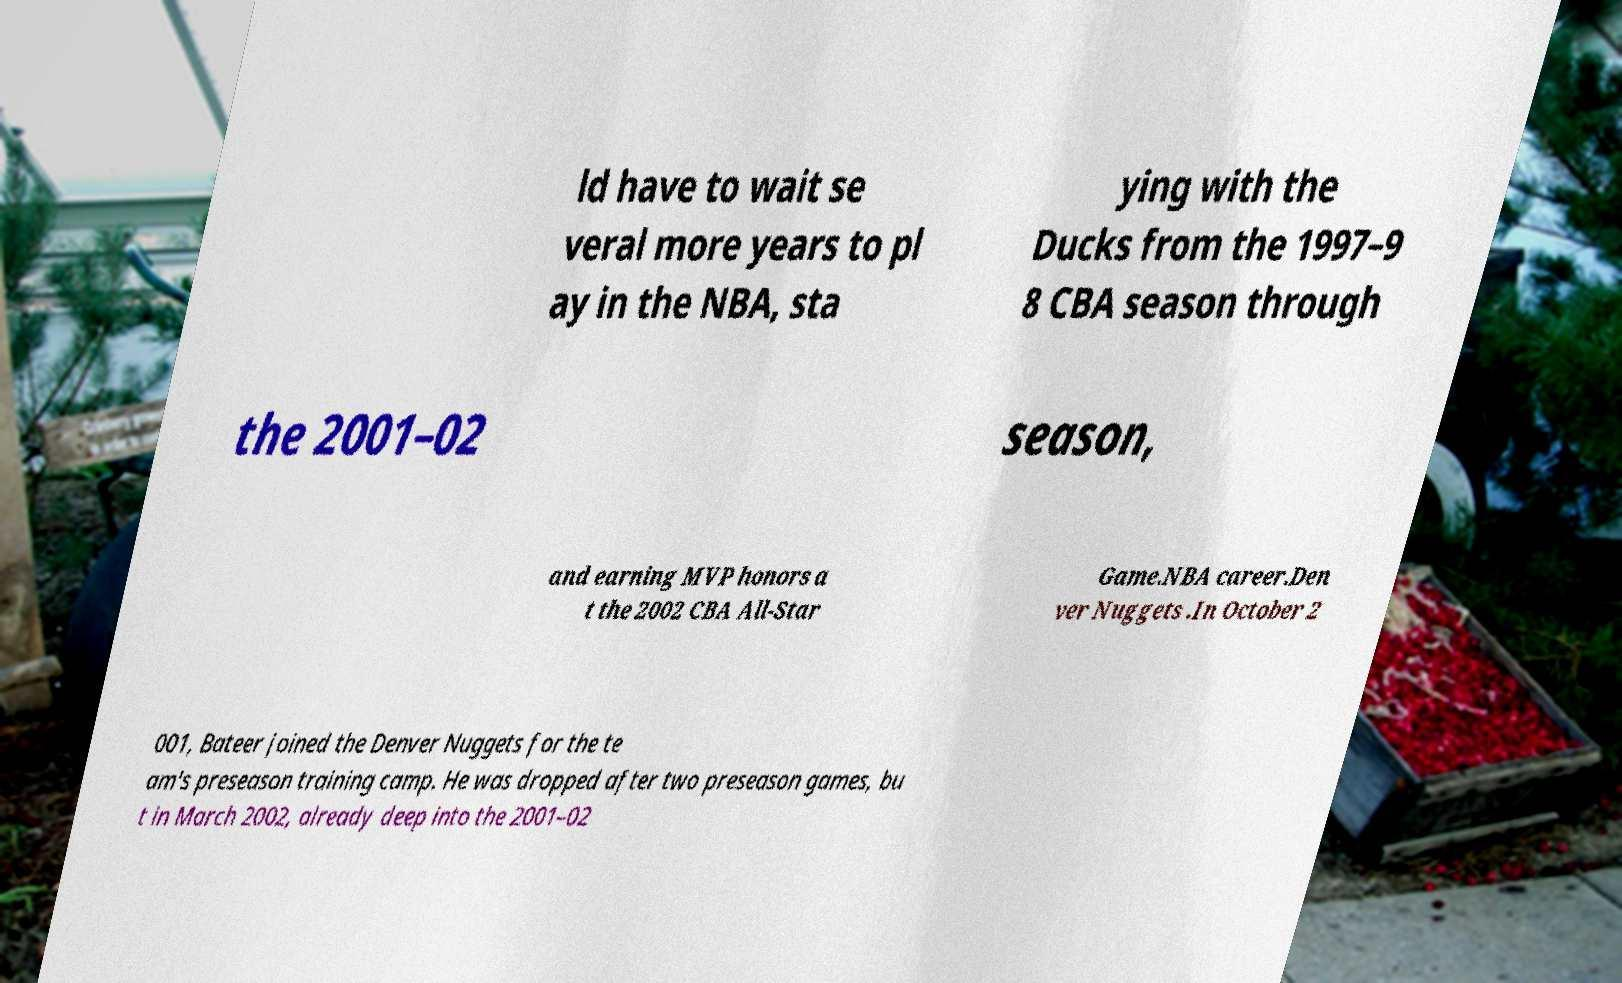Please read and relay the text visible in this image. What does it say? ld have to wait se veral more years to pl ay in the NBA, sta ying with the Ducks from the 1997–9 8 CBA season through the 2001–02 season, and earning MVP honors a t the 2002 CBA All-Star Game.NBA career.Den ver Nuggets .In October 2 001, Bateer joined the Denver Nuggets for the te am's preseason training camp. He was dropped after two preseason games, bu t in March 2002, already deep into the 2001–02 